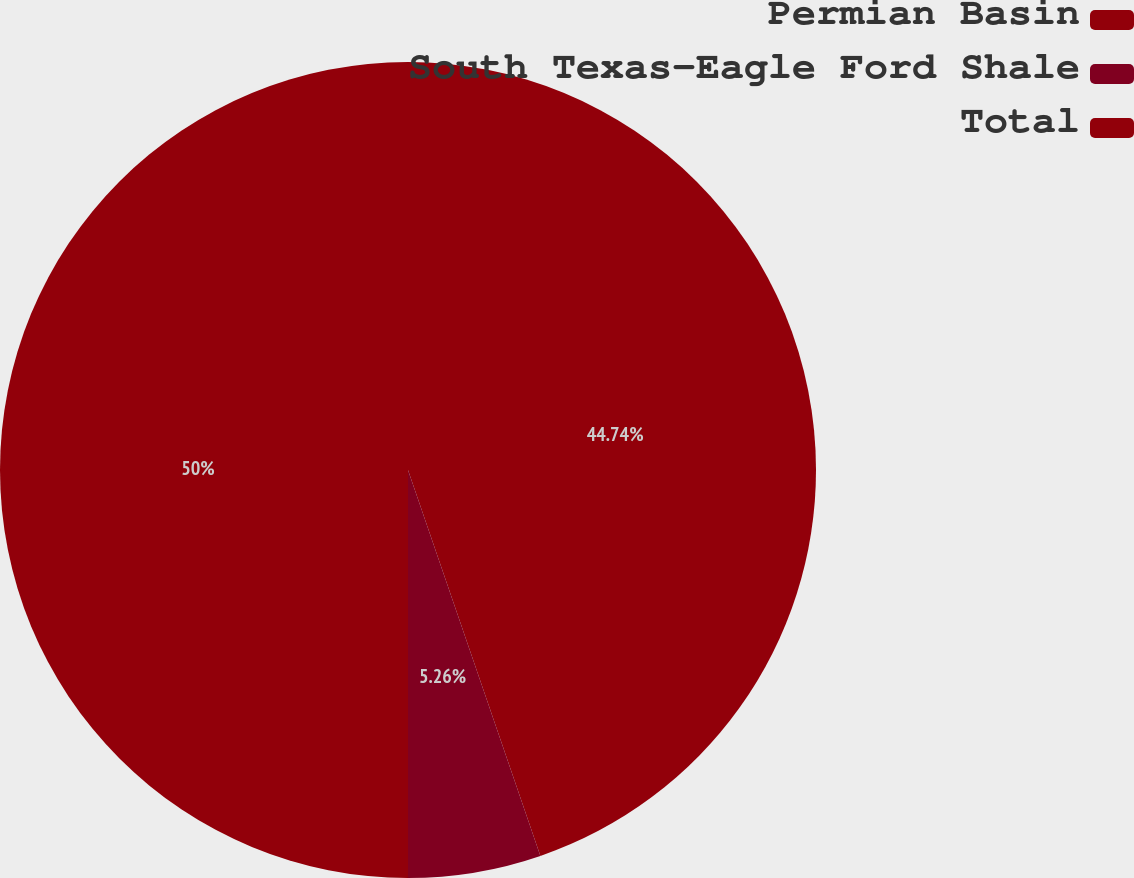Convert chart to OTSL. <chart><loc_0><loc_0><loc_500><loc_500><pie_chart><fcel>Permian Basin<fcel>South Texas-Eagle Ford Shale<fcel>Total<nl><fcel>44.74%<fcel>5.26%<fcel>50.0%<nl></chart> 